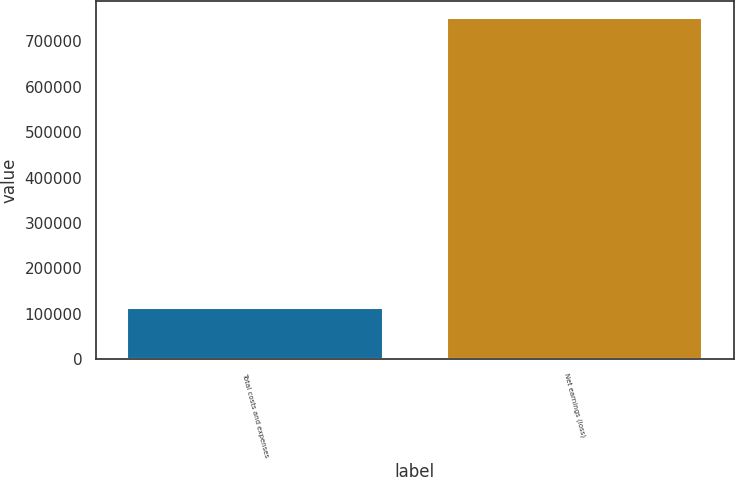Convert chart to OTSL. <chart><loc_0><loc_0><loc_500><loc_500><bar_chart><fcel>Total costs and expenses<fcel>Net earnings (loss)<nl><fcel>111488<fcel>751391<nl></chart> 